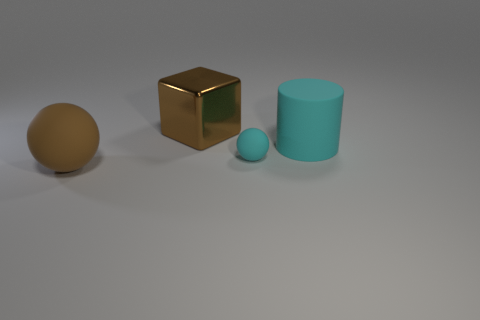Add 1 cyan rubber objects. How many objects exist? 5 Subtract all blocks. How many objects are left? 3 Add 1 brown blocks. How many brown blocks are left? 2 Add 2 tiny purple blocks. How many tiny purple blocks exist? 2 Subtract 0 blue cubes. How many objects are left? 4 Subtract all small balls. Subtract all big brown metal cubes. How many objects are left? 2 